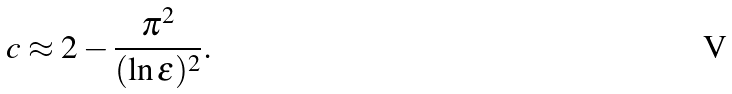Convert formula to latex. <formula><loc_0><loc_0><loc_500><loc_500>c \approx 2 - \frac { \pi ^ { 2 } } { ( \ln \epsilon ) ^ { 2 } } .</formula> 